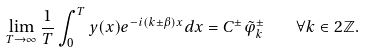<formula> <loc_0><loc_0><loc_500><loc_500>\lim _ { T \to \infty } \frac { 1 } { T } \int _ { 0 } ^ { T } y ( x ) e ^ { - i ( k \pm \beta ) x } d x = C ^ { \pm } \tilde { \varphi } ^ { \pm } _ { k } \quad \forall k \in 2 \mathbb { Z } .</formula> 